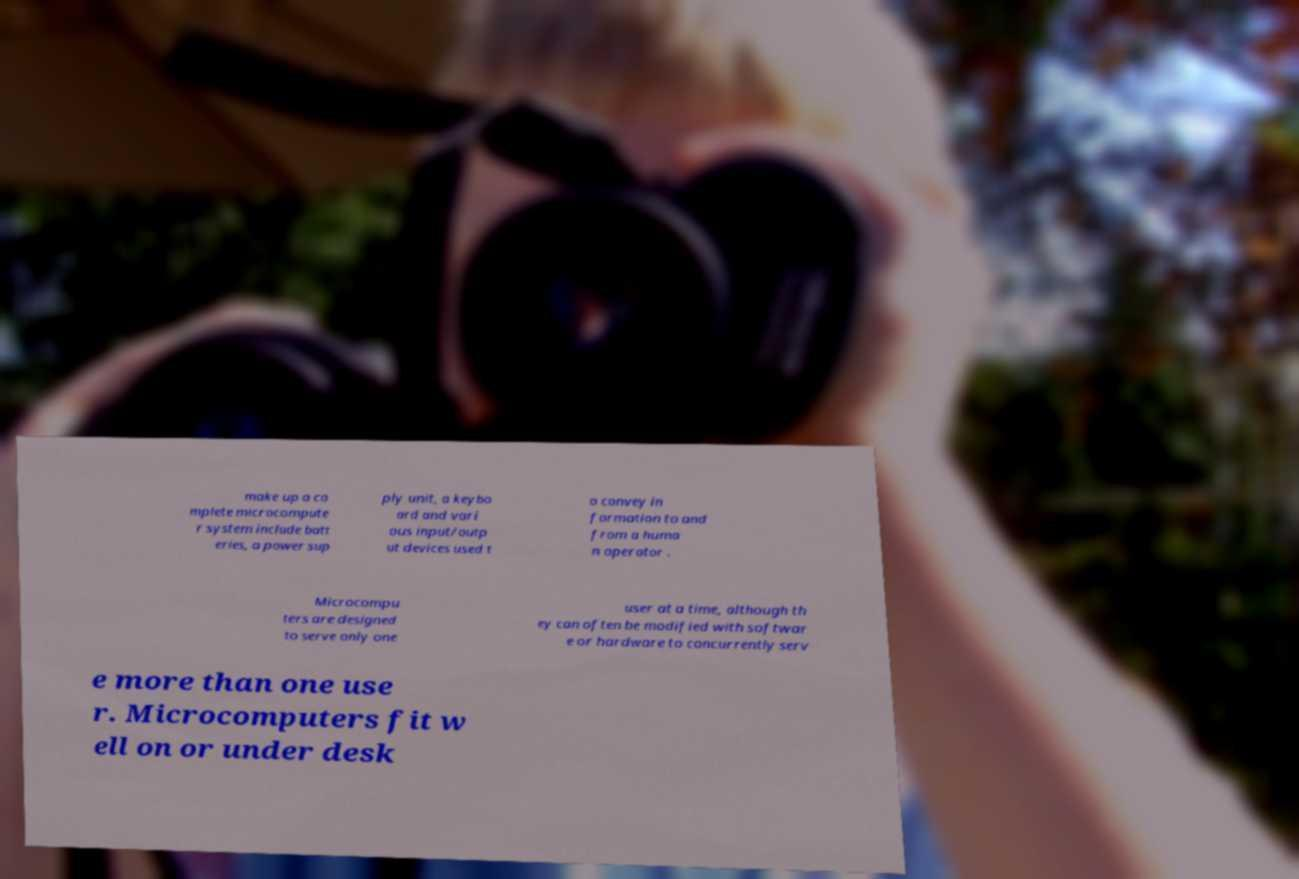Please read and relay the text visible in this image. What does it say? make up a co mplete microcompute r system include batt eries, a power sup ply unit, a keybo ard and vari ous input/outp ut devices used t o convey in formation to and from a huma n operator . Microcompu ters are designed to serve only one user at a time, although th ey can often be modified with softwar e or hardware to concurrently serv e more than one use r. Microcomputers fit w ell on or under desk 